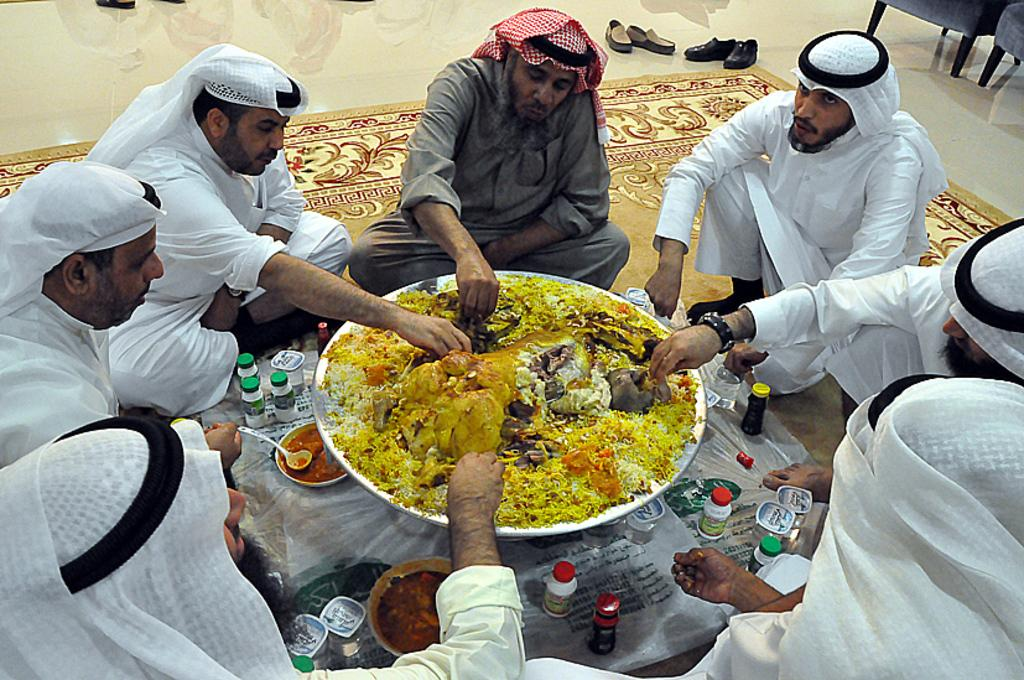What are the persons in the image doing while sitting on the cloth? The persons are eating food. What type of containers can be seen in the image? There are bottles and bowls visible in the image. What utensils are present in the image? Spoons are present in the image. What is the location of the scene in the image? The scene is taking place on the floor. What else can be seen in the image besides the persons and containers? There are shoes in the image. What event is taking place in the image? There is no specific event mentioned in the image; it simply shows persons sitting on a cloth and eating food. What is the plot of the story being told in the image? There is no story being told in the image; it is a simple scene of people eating food on the floor. 